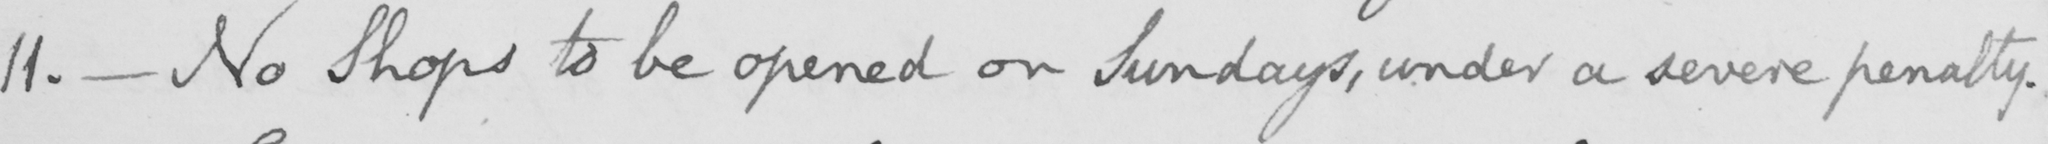Can you read and transcribe this handwriting? 11 .  _  No Shops to be opened on Sundays , under a severe penalty . 